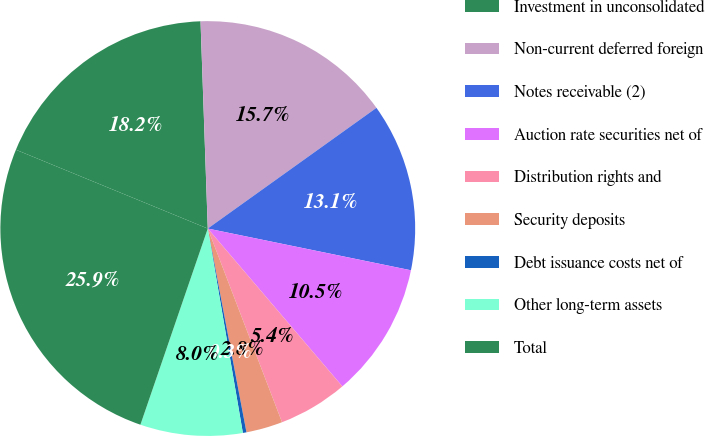Convert chart to OTSL. <chart><loc_0><loc_0><loc_500><loc_500><pie_chart><fcel>Investment in unconsolidated<fcel>Non-current deferred foreign<fcel>Notes receivable (2)<fcel>Auction rate securities net of<fcel>Distribution rights and<fcel>Security deposits<fcel>Debt issuance costs net of<fcel>Other long-term assets<fcel>Total<nl><fcel>18.24%<fcel>15.67%<fcel>13.11%<fcel>10.54%<fcel>5.41%<fcel>2.84%<fcel>0.28%<fcel>7.97%<fcel>25.94%<nl></chart> 